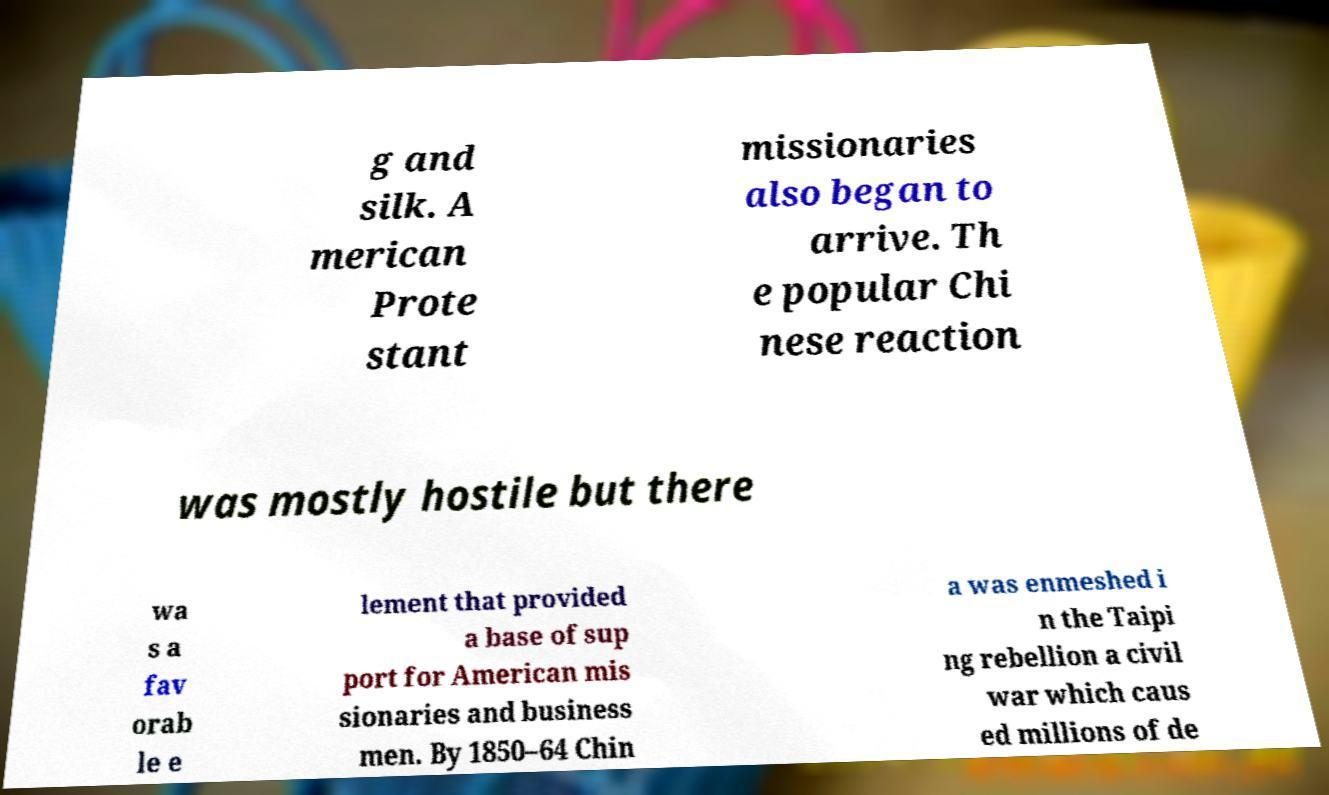Please identify and transcribe the text found in this image. g and silk. A merican Prote stant missionaries also began to arrive. Th e popular Chi nese reaction was mostly hostile but there wa s a fav orab le e lement that provided a base of sup port for American mis sionaries and business men. By 1850–64 Chin a was enmeshed i n the Taipi ng rebellion a civil war which caus ed millions of de 